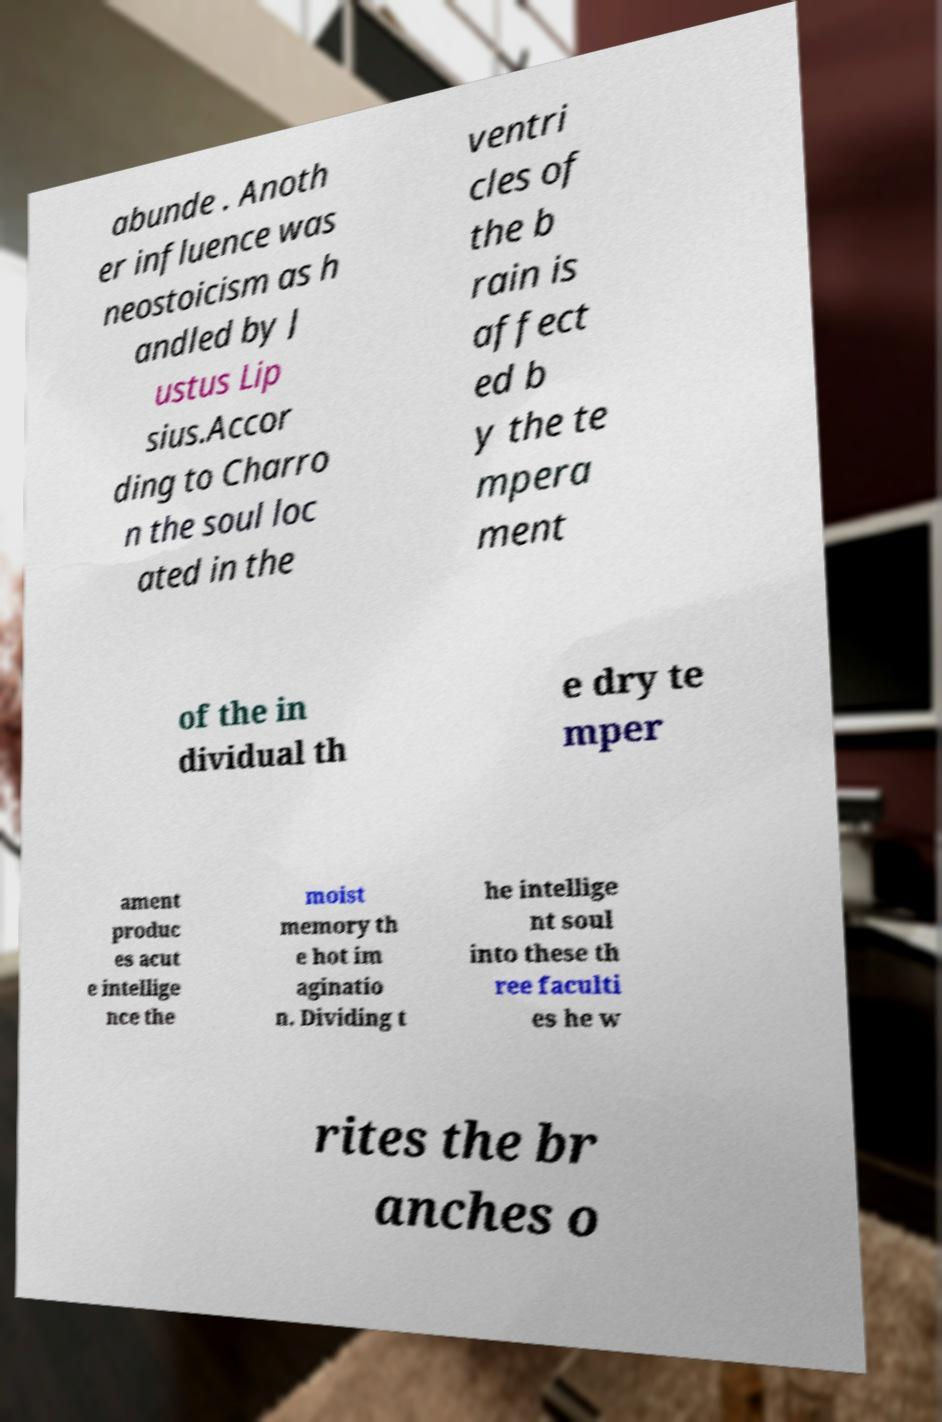What messages or text are displayed in this image? I need them in a readable, typed format. abunde . Anoth er influence was neostoicism as h andled by J ustus Lip sius.Accor ding to Charro n the soul loc ated in the ventri cles of the b rain is affect ed b y the te mpera ment of the in dividual th e dry te mper ament produc es acut e intellige nce the moist memory th e hot im aginatio n. Dividing t he intellige nt soul into these th ree faculti es he w rites the br anches o 